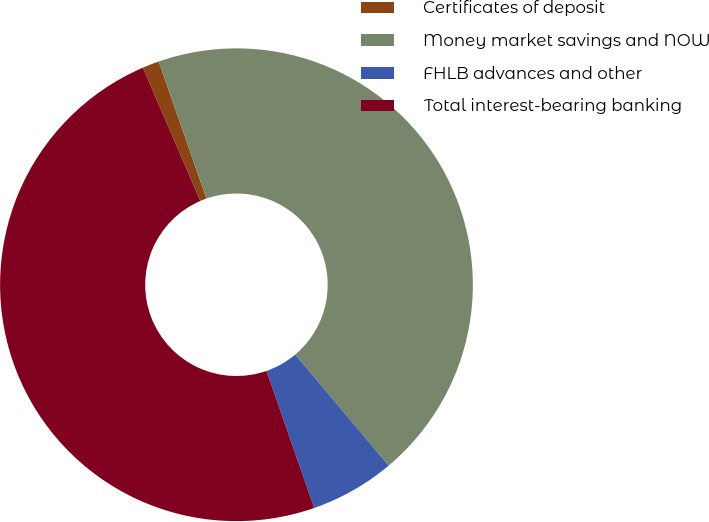Convert chart to OTSL. <chart><loc_0><loc_0><loc_500><loc_500><pie_chart><fcel>Certificates of deposit<fcel>Money market savings and NOW<fcel>FHLB advances and other<fcel>Total interest-bearing banking<nl><fcel>1.15%<fcel>44.2%<fcel>5.8%<fcel>48.85%<nl></chart> 